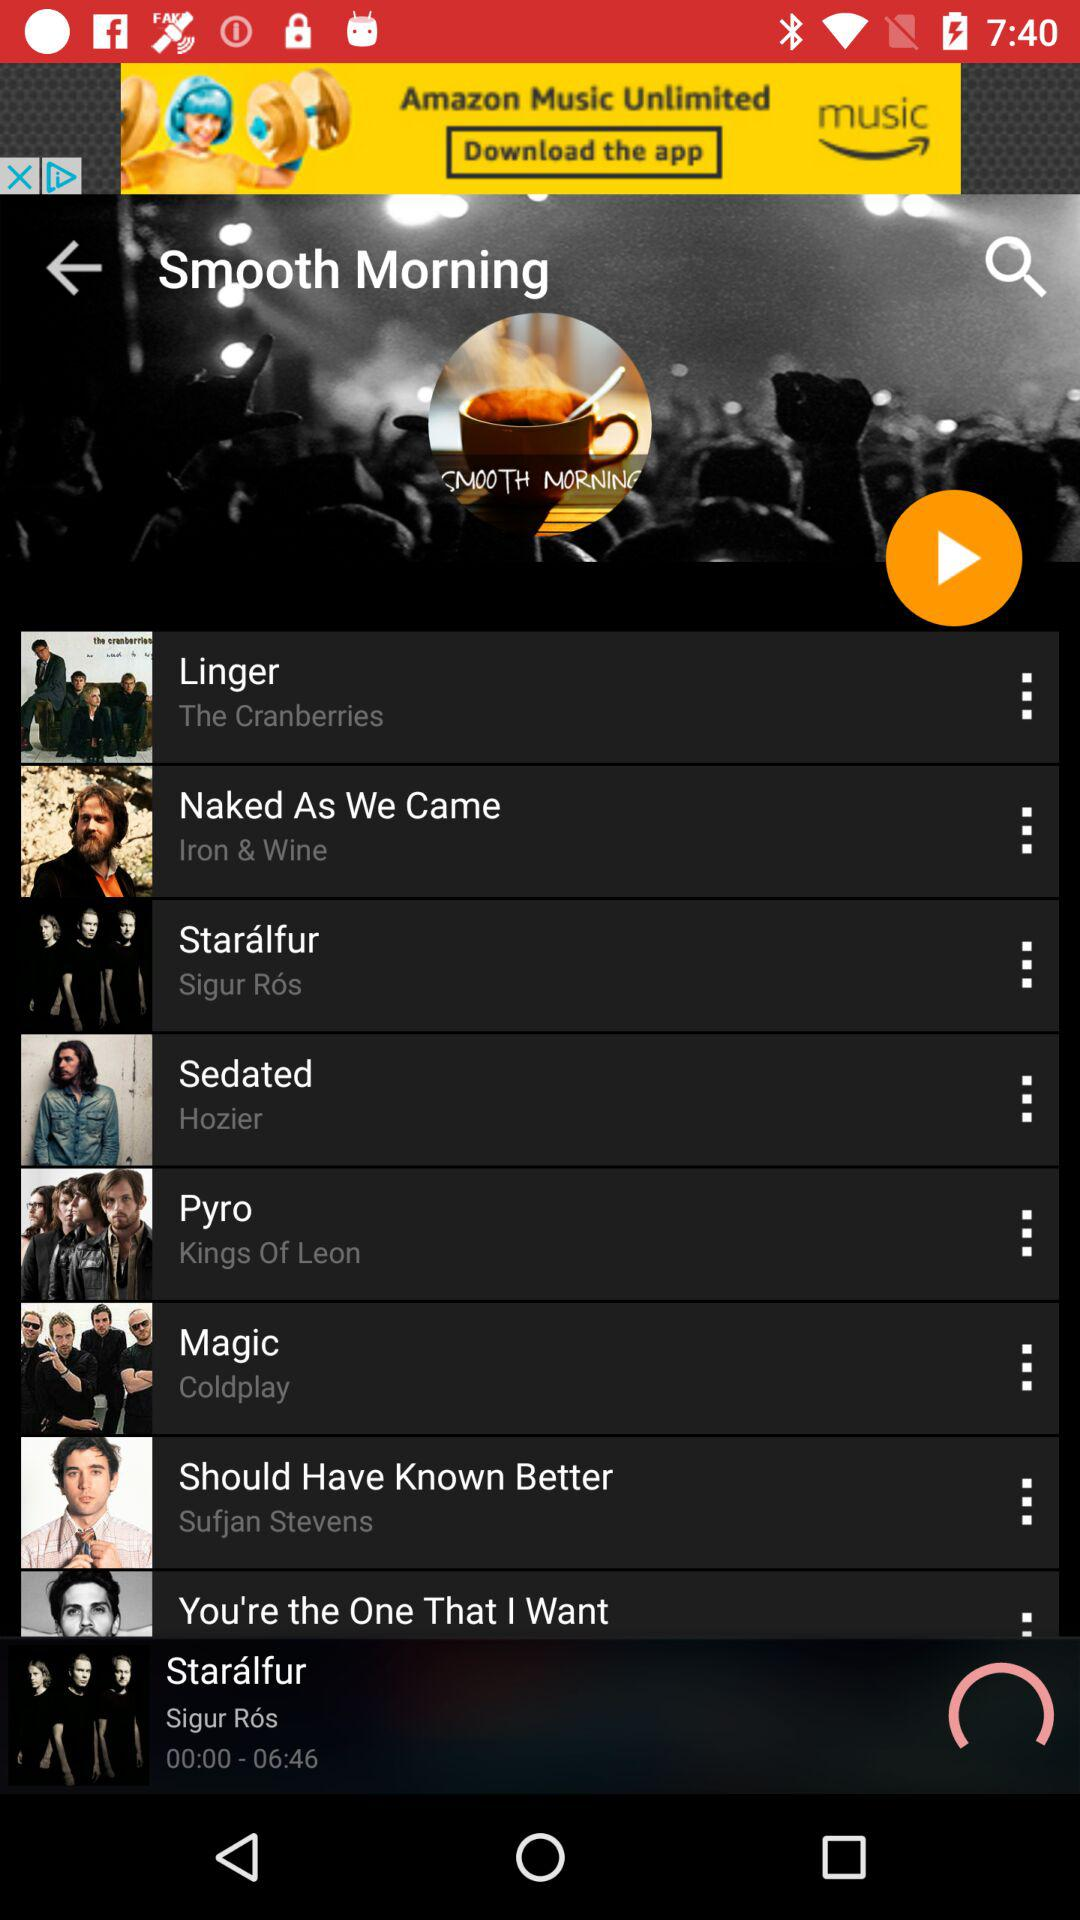What's the duration of the song "Starálfur"? The duration is 6 minutes and 46 seconds. 